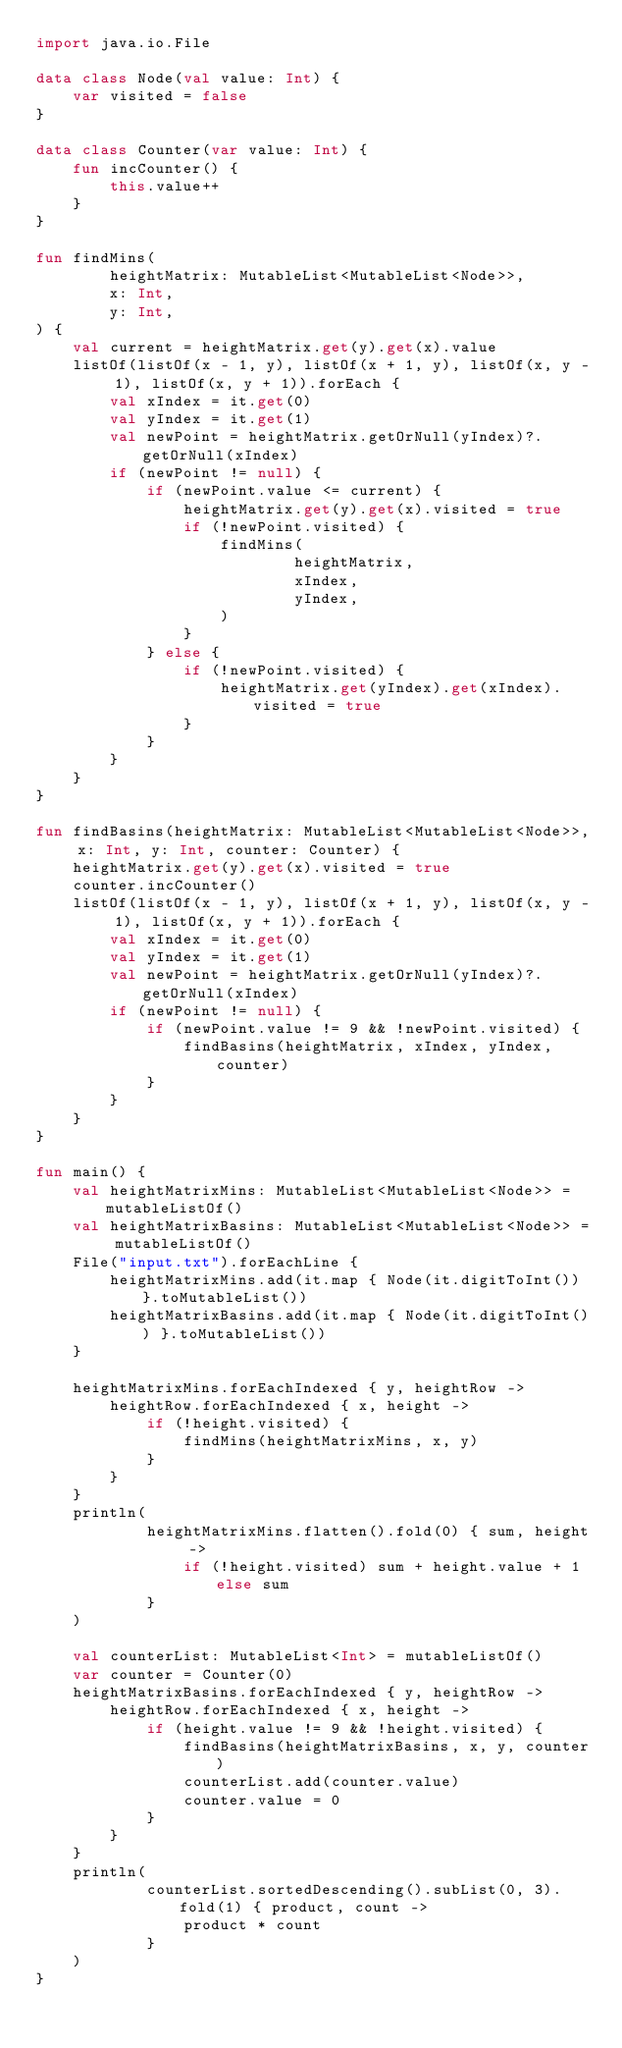Convert code to text. <code><loc_0><loc_0><loc_500><loc_500><_Kotlin_>import java.io.File

data class Node(val value: Int) {
    var visited = false
}

data class Counter(var value: Int) {
    fun incCounter() {
        this.value++
    }
}

fun findMins(
        heightMatrix: MutableList<MutableList<Node>>,
        x: Int,
        y: Int,
) {
    val current = heightMatrix.get(y).get(x).value
    listOf(listOf(x - 1, y), listOf(x + 1, y), listOf(x, y - 1), listOf(x, y + 1)).forEach {
        val xIndex = it.get(0)
        val yIndex = it.get(1)
        val newPoint = heightMatrix.getOrNull(yIndex)?.getOrNull(xIndex)
        if (newPoint != null) {
            if (newPoint.value <= current) {
                heightMatrix.get(y).get(x).visited = true
                if (!newPoint.visited) {
                    findMins(
                            heightMatrix,
                            xIndex,
                            yIndex,
                    )
                }
            } else {
                if (!newPoint.visited) {
                    heightMatrix.get(yIndex).get(xIndex).visited = true
                }
            }
        }
    }
}

fun findBasins(heightMatrix: MutableList<MutableList<Node>>, x: Int, y: Int, counter: Counter) {
    heightMatrix.get(y).get(x).visited = true
    counter.incCounter()
    listOf(listOf(x - 1, y), listOf(x + 1, y), listOf(x, y - 1), listOf(x, y + 1)).forEach {
        val xIndex = it.get(0)
        val yIndex = it.get(1)
        val newPoint = heightMatrix.getOrNull(yIndex)?.getOrNull(xIndex)
        if (newPoint != null) {
            if (newPoint.value != 9 && !newPoint.visited) {
                findBasins(heightMatrix, xIndex, yIndex, counter)
            }
        }
    }
}

fun main() {
    val heightMatrixMins: MutableList<MutableList<Node>> = mutableListOf()
    val heightMatrixBasins: MutableList<MutableList<Node>> = mutableListOf()
    File("input.txt").forEachLine {
        heightMatrixMins.add(it.map { Node(it.digitToInt()) }.toMutableList())
        heightMatrixBasins.add(it.map { Node(it.digitToInt()) }.toMutableList())
    }

    heightMatrixMins.forEachIndexed { y, heightRow ->
        heightRow.forEachIndexed { x, height ->
            if (!height.visited) {
                findMins(heightMatrixMins, x, y)
            }
        }
    }
    println(
            heightMatrixMins.flatten().fold(0) { sum, height ->
                if (!height.visited) sum + height.value + 1 else sum
            }
    )

    val counterList: MutableList<Int> = mutableListOf()
    var counter = Counter(0)
    heightMatrixBasins.forEachIndexed { y, heightRow ->
        heightRow.forEachIndexed { x, height ->
            if (height.value != 9 && !height.visited) {
                findBasins(heightMatrixBasins, x, y, counter)
                counterList.add(counter.value)
                counter.value = 0
            }
        }
    }
    println(
            counterList.sortedDescending().subList(0, 3).fold(1) { product, count ->
                product * count
            }
    )
}
</code> 